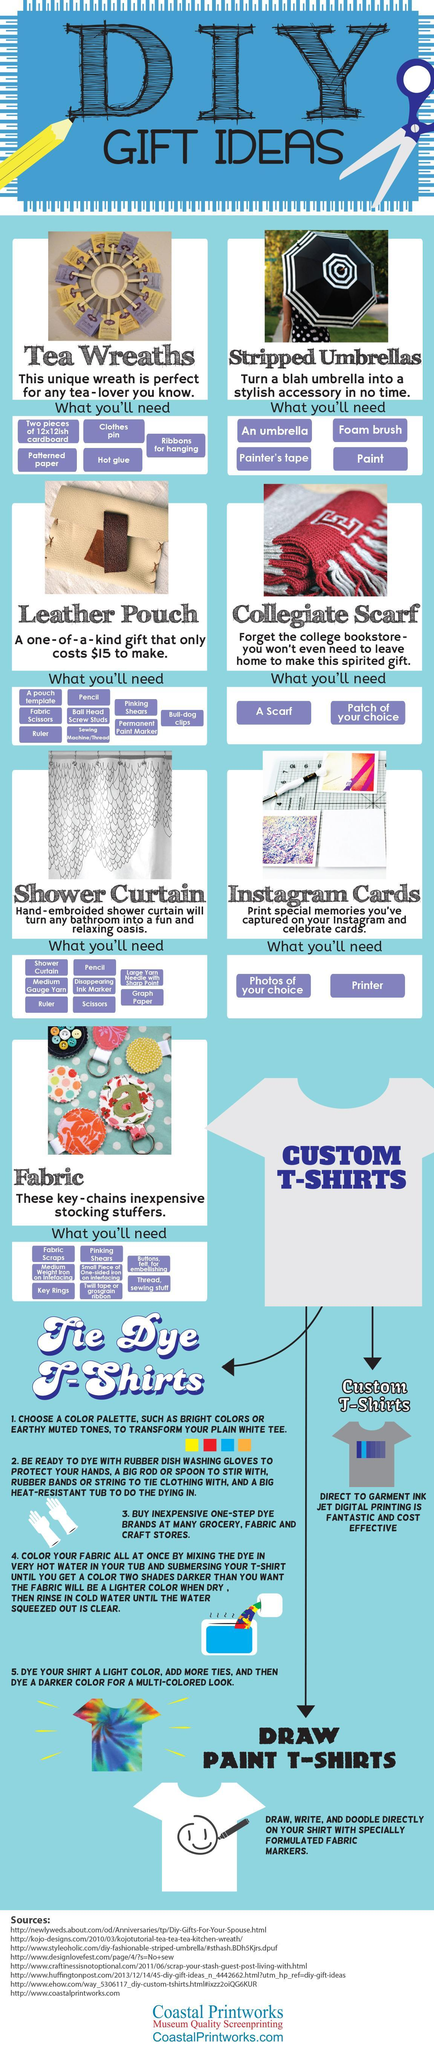how many types of t-shirts have been mentioned?
Answer the question with a short phrase. 3 which gift idea in the picture has a colour combination of white and black stripped umbrellas which gift idea needs a printer? instagram cards which t-shirt has a smiley drawn on it paint t-shirts in which gift idea is the rate given? leather pouch in which step is a uniform colour given to the fabric 4 